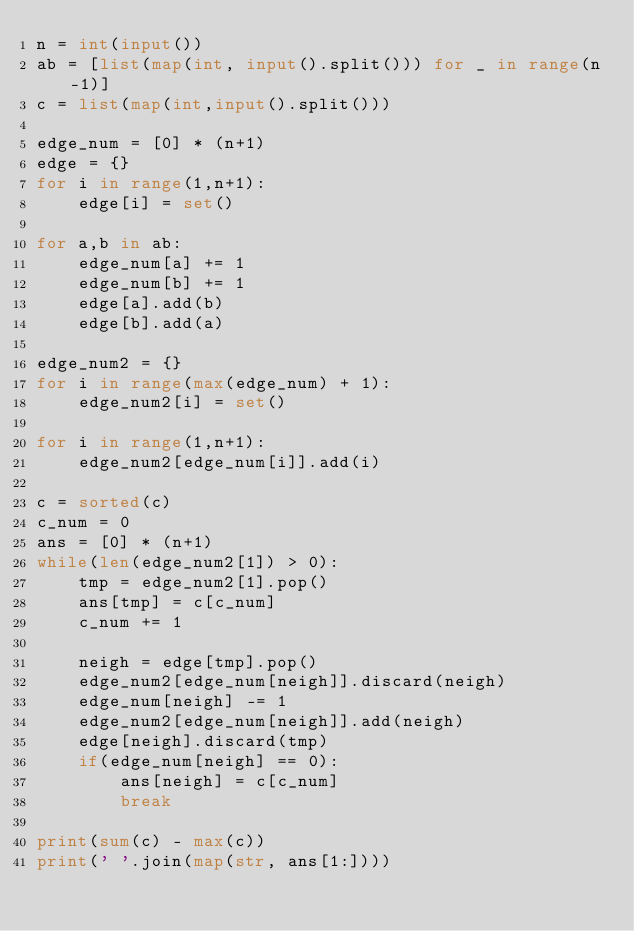<code> <loc_0><loc_0><loc_500><loc_500><_Python_>n = int(input())
ab = [list(map(int, input().split())) for _ in range(n-1)]
c = list(map(int,input().split()))

edge_num = [0] * (n+1)
edge = {}
for i in range(1,n+1):
    edge[i] = set()

for a,b in ab:
    edge_num[a] += 1
    edge_num[b] += 1
    edge[a].add(b)
    edge[b].add(a)

edge_num2 = {}
for i in range(max(edge_num) + 1):
    edge_num2[i] = set()

for i in range(1,n+1):
    edge_num2[edge_num[i]].add(i)

c = sorted(c)
c_num = 0
ans = [0] * (n+1)
while(len(edge_num2[1]) > 0):
    tmp = edge_num2[1].pop()
    ans[tmp] = c[c_num]
    c_num += 1

    neigh = edge[tmp].pop()
    edge_num2[edge_num[neigh]].discard(neigh)
    edge_num[neigh] -= 1
    edge_num2[edge_num[neigh]].add(neigh)
    edge[neigh].discard(tmp)
    if(edge_num[neigh] == 0):
        ans[neigh] = c[c_num]
        break

print(sum(c) - max(c))
print(' '.join(map(str, ans[1:])))</code> 